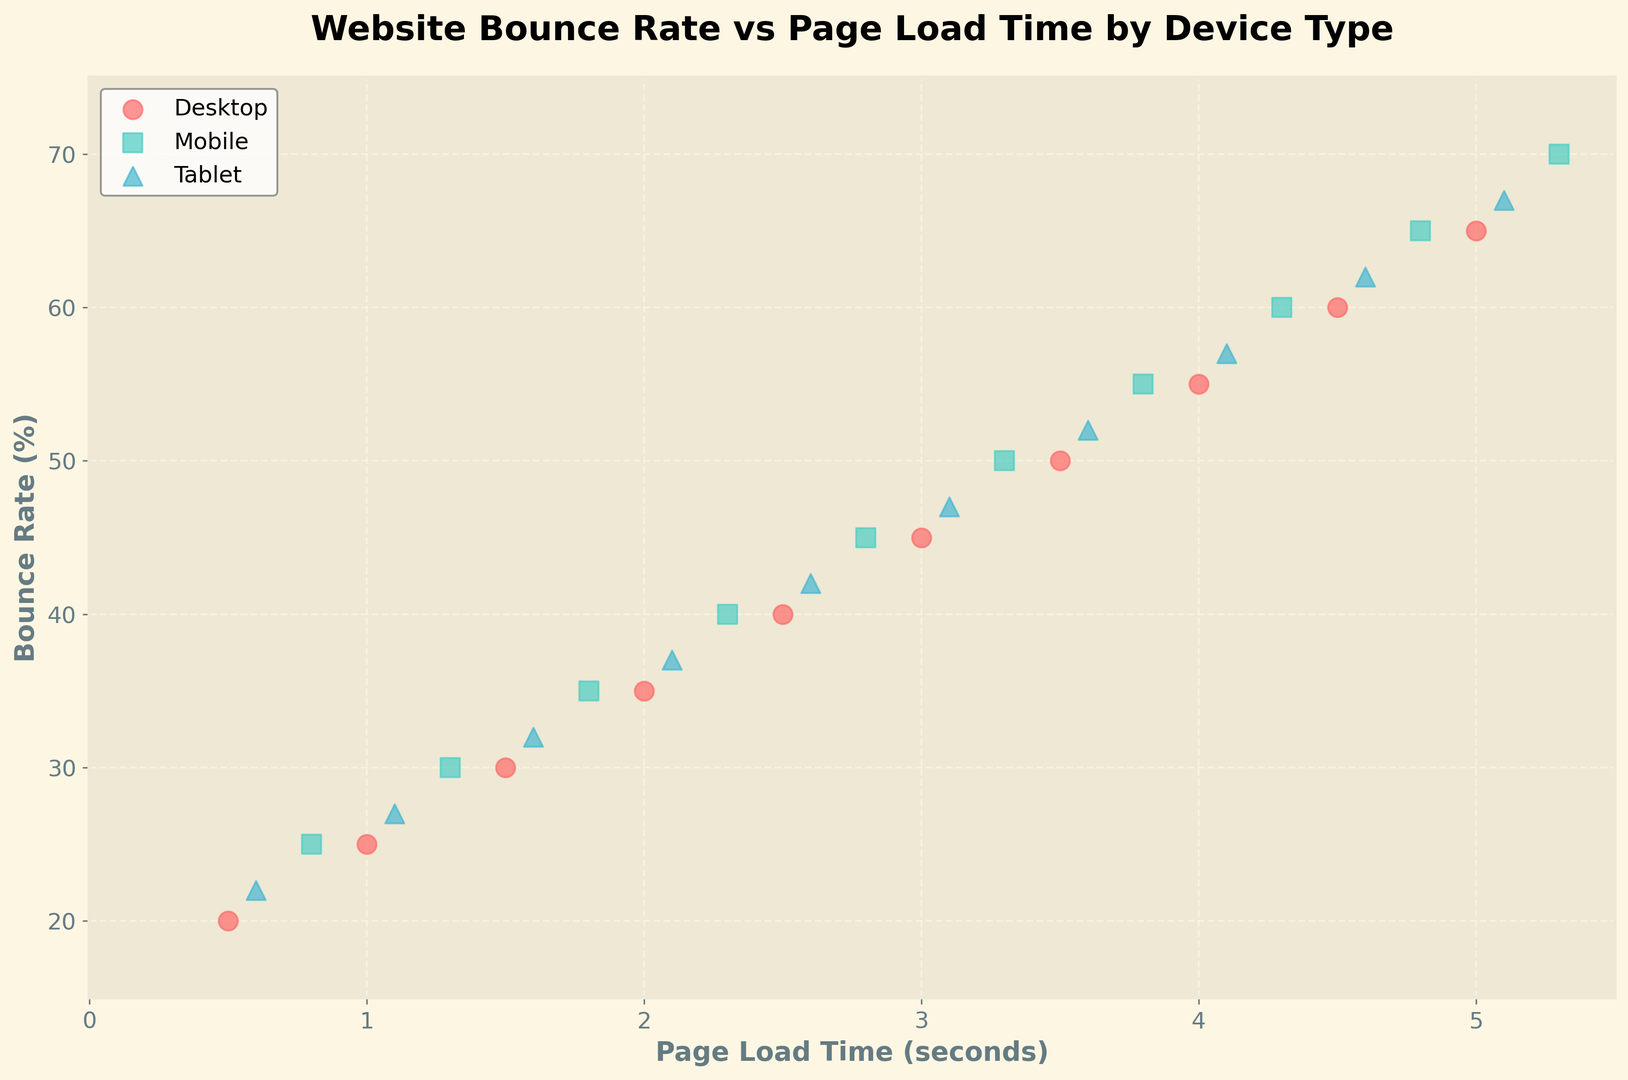What is the bounce rate for desktops when the page load time is 2.0 seconds? First, locate the point where the device type is 'desktop' and page load time is 2.0 seconds on the scatter plot. The corresponding bounce rate value is located by looking at the y-axis.
Answer: 35% Which device type has the highest bounce rate at a page load time of 4.8 seconds? Locate the page load time of 4.8 seconds on the x-axis and find the corresponding markers for different device types. Compare their bounce rates, indicated on the y-axis, to determine the highest one.
Answer: Mobile What is the difference in bounce rates between desktops and tablets at a page load time of 3.0 seconds? Identify the bounce rates for desktops and tablets at 3.0 seconds from the scatter plot. For desktops, it's 45%, and for tablets, it's 47%. Subtract the lower value from the higher value to find the difference.
Answer: 2% Which device type generally shows a higher bounce rate for the same page load times, mobile or desktop? Compare the scatter points for mobile and desktop across multiple page load times. For each time unit, the mobile markers (squares) are generally higher on the y-axis than the desktop markers (circles), indicating higher bounce rates for mobile.
Answer: Mobile At which page load time does the bounce rate for tablets reach 57%? Look for the tablet markers (triangles) on the scatter plot and find the point where the bounce rate on the y-axis is 57%. The corresponding x-axis value is the page load time.
Answer: 4.1 seconds Which has a greater spread in bounce rates, desktop or mobile devices? Examine the range of bounce rates for both device types on the y-axis. Desktops range from 20% to 65%, while mobiles range from 25% to 70%, indicating that mobiles have a slightly wider spread.
Answer: Mobile devices What is the average bounce rate of all device types at a page load time of 1.5 seconds? Identify the bounce rates for all device types at 1.5 seconds: desktop(30%), mobile(35%), and tablet(32%). Calculate the average by summing these values and dividing by the number of data points (30 + 35 + 32) / 3 = 32.33.
Answer: 32.33% Which page load time has the highest bounce rate among all device types? Locate the highest point on the y-axis for each device type and check the corresponding page load time on the x-axis. The highest bounce rate is 70% at 5.3 seconds for mobile devices.
Answer: 5.3 seconds 